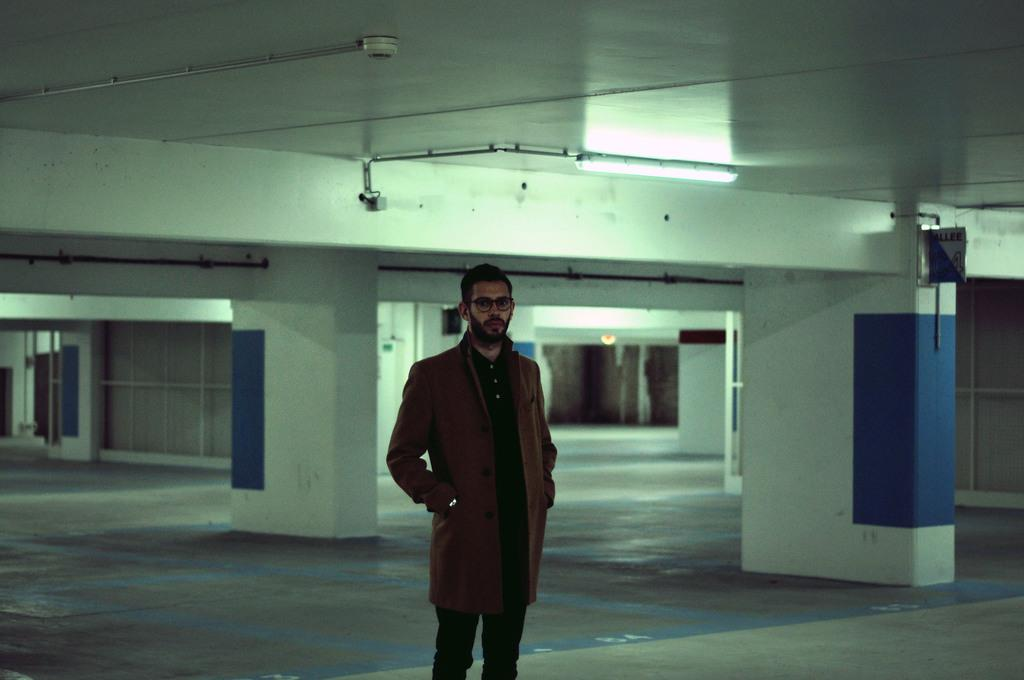Who is present in the image? There is a man in the image. What is the man wearing in the image? The man is wearing spectacles in the image. What is the man's position in the image? The man is standing on the floor in the image. What architectural features can be seen in the image? There are pillars in the image. What type of illumination is present in the image? There is a light in the image. What other objects can be seen in the image? There are pipes in the image. What is visible in the background of the image? There is a wall in the background of the image. What type of powder is being used by the man in the image? There is no powder present in the image; the man is simply standing on the floor. What type of rail can be seen in the image? There is no rail present in the image; the image features pillars and pipes instead. 